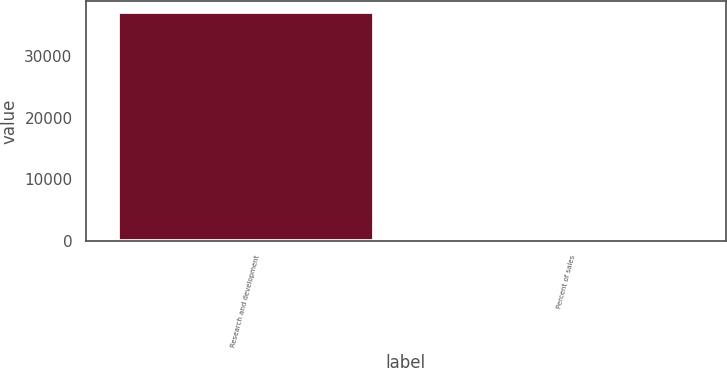Convert chart. <chart><loc_0><loc_0><loc_500><loc_500><bar_chart><fcel>Research and development<fcel>Percent of sales<nl><fcel>37093<fcel>5.6<nl></chart> 